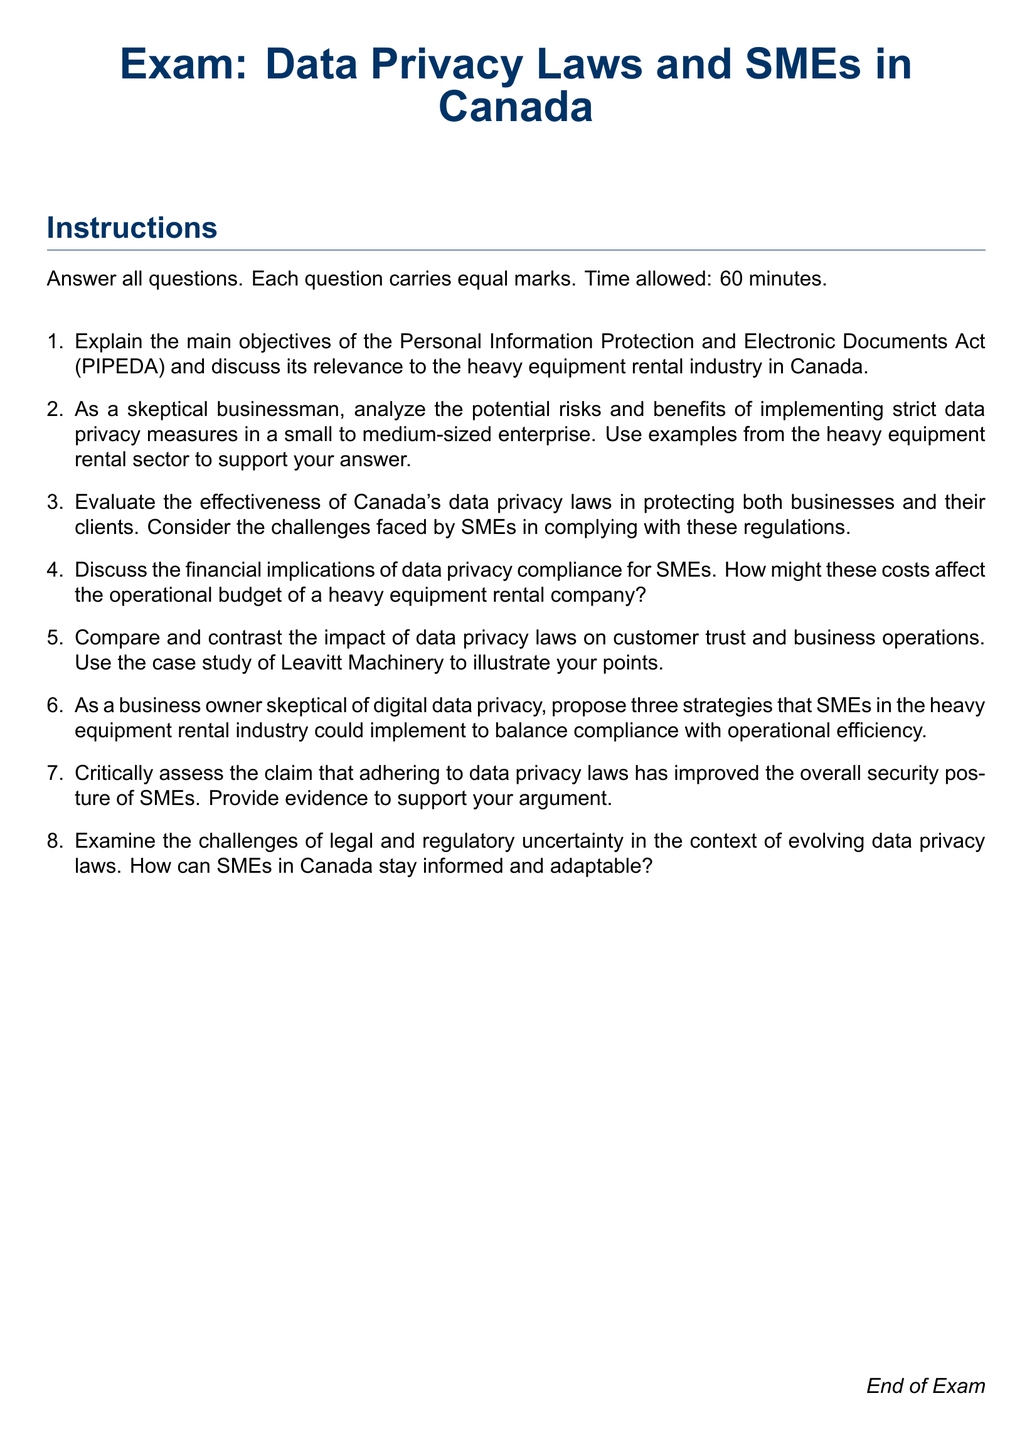What is the title of the exam? The title of the exam is stated at the top of the document.
Answer: Data Privacy Laws and SMEs in Canada How many questions are in the exam? The document lists a total of eight questions under the enumerated list.
Answer: 8 What is the time allowed for the exam? The document specifies the time duration allowed for the exam at the beginning.
Answer: 60 minutes What is the main legislation discussed in the exam? The primary legislation mentioned in the first question is explicitly named.
Answer: PIPEDA Which industry does the exam specifically relate to in the context of SMEs? The document highlights a specific industry in the first question of the exam.
Answer: Heavy equipment rental What is the purpose of the investigations into data privacy compliance? The rationale behind the questions is to determine the impact on SMEs, as noted throughout the exam.
Answer: To evaluate the effectiveness of data privacy laws How many marks does each question carry? The document states the scoring method at the beginning of the exam.
Answer: Equal marks What could be one of the proposed strategies for SMEs? The last question asks for strategies without specifying, but it implies practical solutions.
Answer: Three strategies 